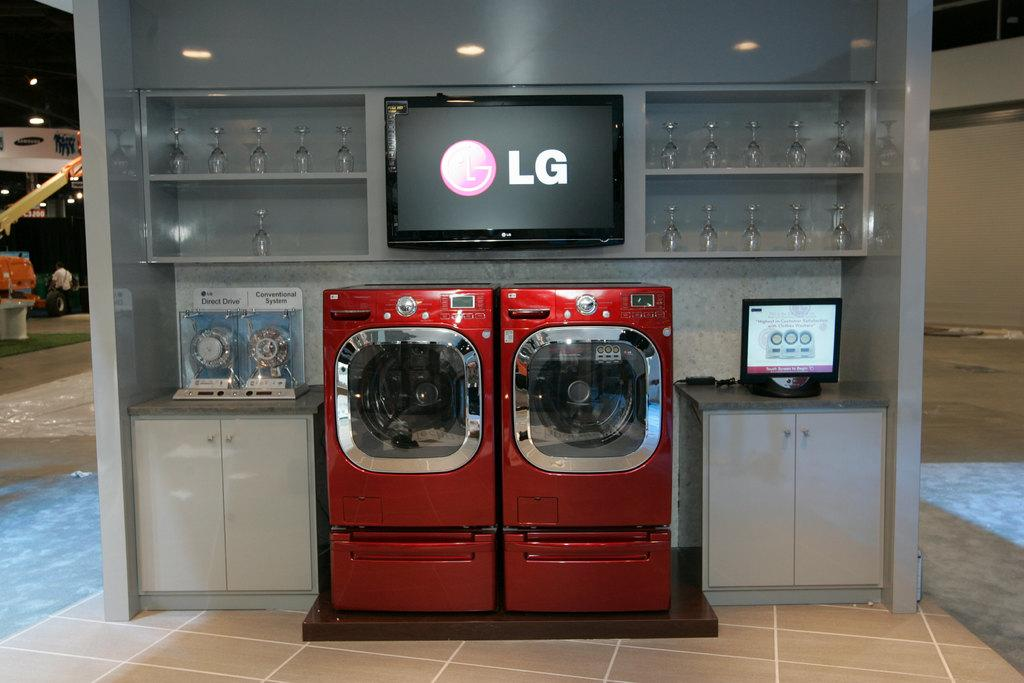<image>
Summarize the visual content of the image. an LG red washer and dryer display. 